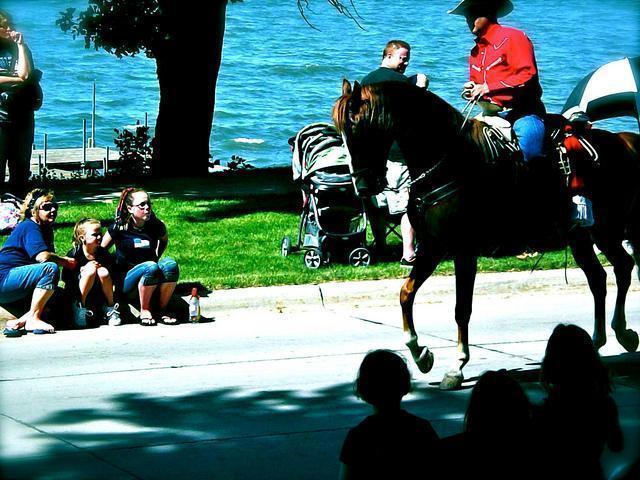The Horse and rider here are part of what?
Select the accurate response from the four choices given to answer the question.
Options: Runaway horse, parade, rodeo roundup, escape. Parade. 